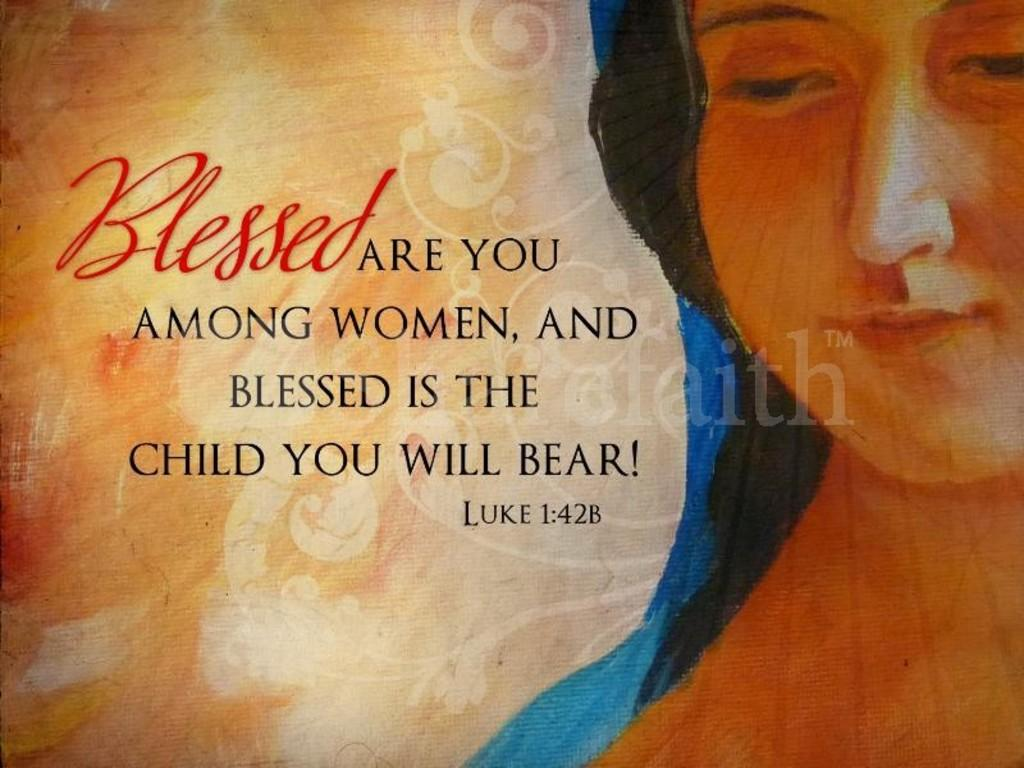What is depicted on the poster in the image? The poster contains a painting of a woman. Can you describe any additional design elements on the poster? Yes, the poster has designs. What other type of content is featured on the poster besides the painting? The poster includes texts. How many bears can be seen interacting with the stem of the poster? There are no bears present on the poster, and therefore no interaction with the stem can be observed. 